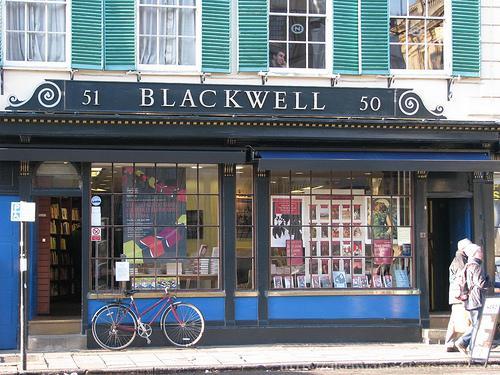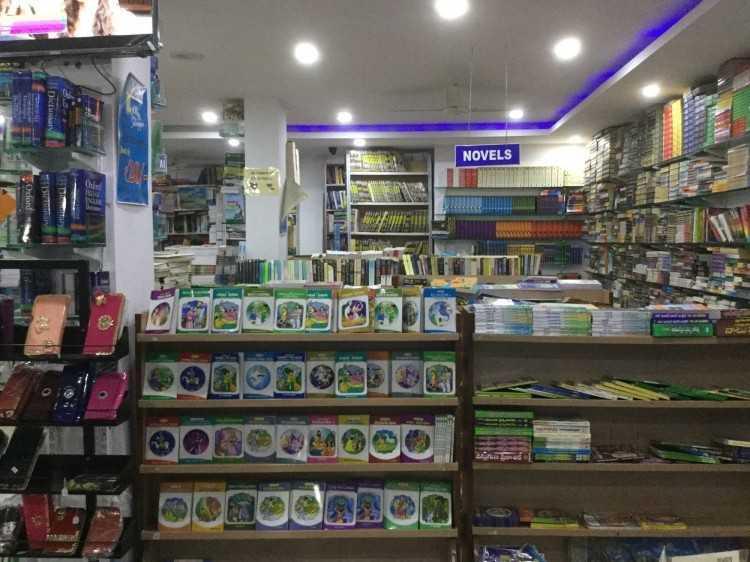The first image is the image on the left, the second image is the image on the right. Evaluate the accuracy of this statement regarding the images: "One image is a bookstore interior featuring bright red-orange on the wall above black bookshelves, and a sculptural red-orange furniture piece in front of the shelves.". Is it true? Answer yes or no. No. The first image is the image on the left, the second image is the image on the right. Examine the images to the left and right. Is the description "the book store is being viewed from the second floor" accurate? Answer yes or no. No. 